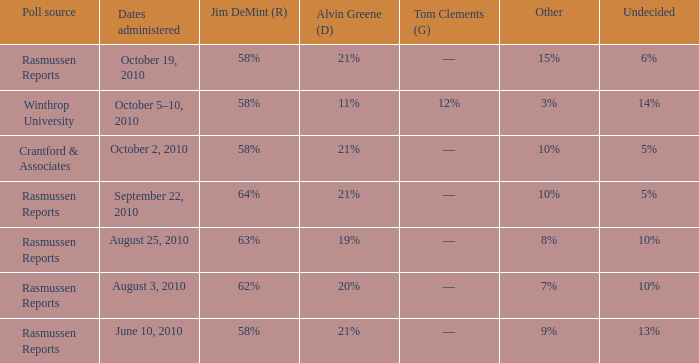Which poll source had an other of 15%? Rasmussen Reports. Could you parse the entire table as a dict? {'header': ['Poll source', 'Dates administered', 'Jim DeMint (R)', 'Alvin Greene (D)', 'Tom Clements (G)', 'Other', 'Undecided'], 'rows': [['Rasmussen Reports', 'October 19, 2010', '58%', '21%', '––', '15%', '6%'], ['Winthrop University', 'October 5–10, 2010', '58%', '11%', '12%', '3%', '14%'], ['Crantford & Associates', 'October 2, 2010', '58%', '21%', '––', '10%', '5%'], ['Rasmussen Reports', 'September 22, 2010', '64%', '21%', '––', '10%', '5%'], ['Rasmussen Reports', 'August 25, 2010', '63%', '19%', '––', '8%', '10%'], ['Rasmussen Reports', 'August 3, 2010', '62%', '20%', '––', '7%', '10%'], ['Rasmussen Reports', 'June 10, 2010', '58%', '21%', '––', '9%', '13%']]} 